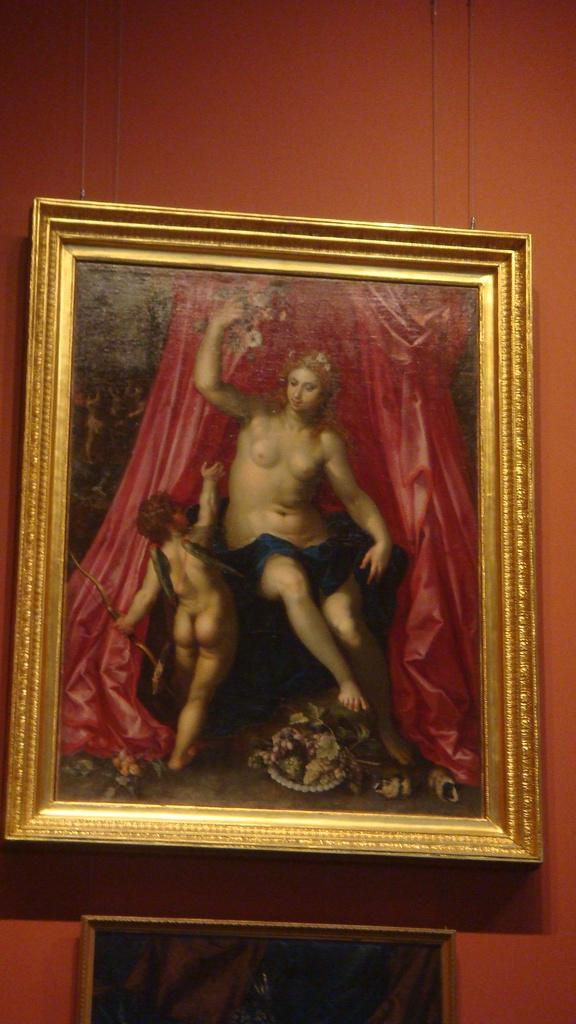What objects can be seen in the image that are related to photographs? There are two photo frames in the image. Where are the photo frames located? The photo frames are placed on a brown wall. Can you tell me how many wheels are visible in the image? There are no wheels present in the image. What type of trick can be seen being performed in the image? There is no trick being performed in the image; it features two photo frames on a brown wall. 